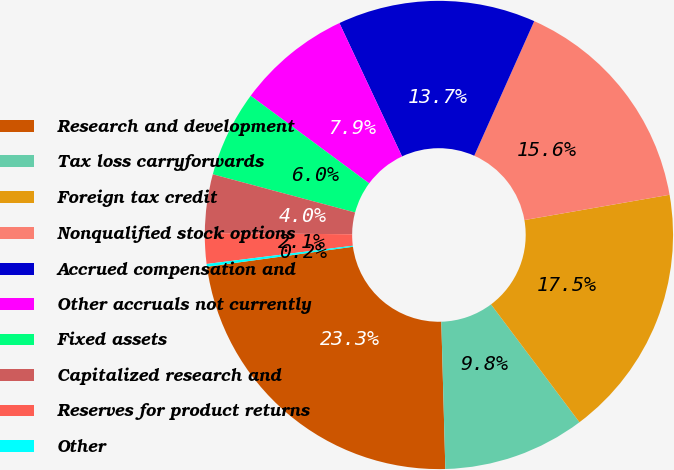Convert chart to OTSL. <chart><loc_0><loc_0><loc_500><loc_500><pie_chart><fcel>Research and development<fcel>Tax loss carryforwards<fcel>Foreign tax credit<fcel>Nonqualified stock options<fcel>Accrued compensation and<fcel>Other accruals not currently<fcel>Fixed assets<fcel>Capitalized research and<fcel>Reserves for product returns<fcel>Other<nl><fcel>23.27%<fcel>9.81%<fcel>17.5%<fcel>15.58%<fcel>13.66%<fcel>7.88%<fcel>5.96%<fcel>4.04%<fcel>2.11%<fcel>0.19%<nl></chart> 